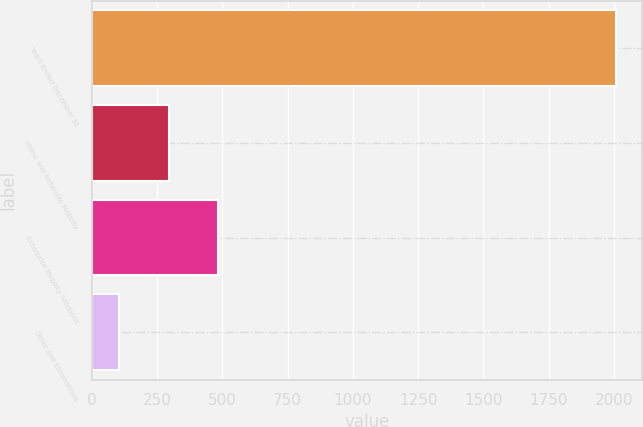Convert chart. <chart><loc_0><loc_0><loc_500><loc_500><bar_chart><fcel>Years Ended December 31<fcel>Home and Networks Mobility<fcel>Enterprise Mobility Solutions<fcel>Other and Eliminations<nl><fcel>2008<fcel>293.5<fcel>484<fcel>103<nl></chart> 